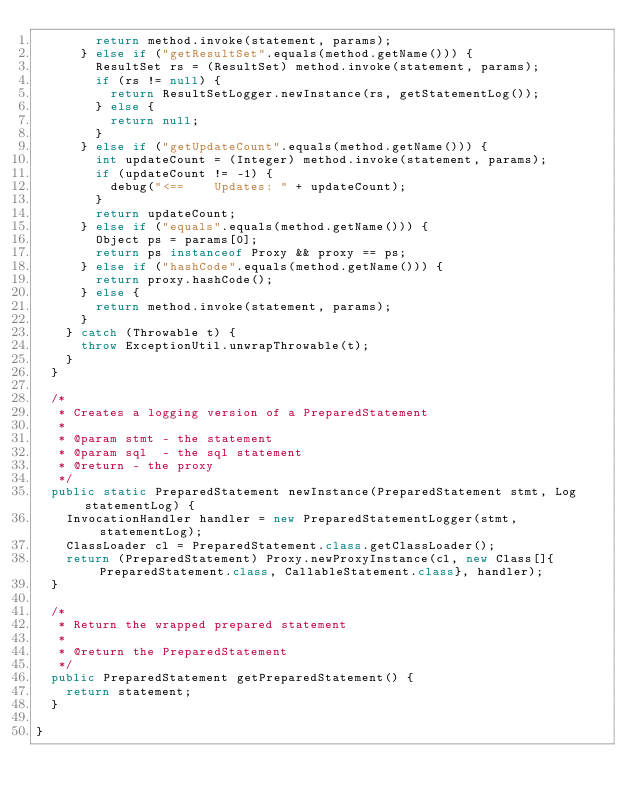Convert code to text. <code><loc_0><loc_0><loc_500><loc_500><_Java_>        return method.invoke(statement, params);
      } else if ("getResultSet".equals(method.getName())) {
        ResultSet rs = (ResultSet) method.invoke(statement, params);
        if (rs != null) {
          return ResultSetLogger.newInstance(rs, getStatementLog());
        } else {
          return null;
        }
      } else if ("getUpdateCount".equals(method.getName())) {
        int updateCount = (Integer) method.invoke(statement, params);
        if (updateCount != -1) {
          debug("<==    Updates: " + updateCount);
        }
        return updateCount;
      } else if ("equals".equals(method.getName())) {
        Object ps = params[0];
        return ps instanceof Proxy && proxy == ps;
      } else if ("hashCode".equals(method.getName())) {
        return proxy.hashCode();
      } else {
        return method.invoke(statement, params);
      }
    } catch (Throwable t) {
      throw ExceptionUtil.unwrapThrowable(t);
    }
  }

  /*
   * Creates a logging version of a PreparedStatement
   *
   * @param stmt - the statement
   * @param sql  - the sql statement
   * @return - the proxy
   */
  public static PreparedStatement newInstance(PreparedStatement stmt, Log statementLog) {
    InvocationHandler handler = new PreparedStatementLogger(stmt, statementLog);
    ClassLoader cl = PreparedStatement.class.getClassLoader();
    return (PreparedStatement) Proxy.newProxyInstance(cl, new Class[]{PreparedStatement.class, CallableStatement.class}, handler);
  }

  /*
   * Return the wrapped prepared statement
   *
   * @return the PreparedStatement
   */
  public PreparedStatement getPreparedStatement() {
    return statement;
  }

}
</code> 